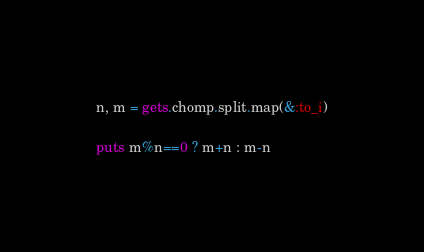<code> <loc_0><loc_0><loc_500><loc_500><_Ruby_>n, m = gets.chomp.split.map(&:to_i)

puts m%n==0 ? m+n : m-n
</code> 